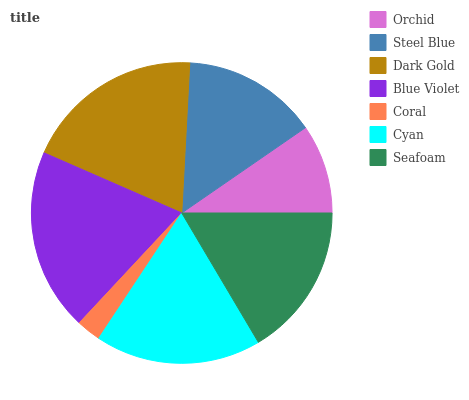Is Coral the minimum?
Answer yes or no. Yes. Is Blue Violet the maximum?
Answer yes or no. Yes. Is Steel Blue the minimum?
Answer yes or no. No. Is Steel Blue the maximum?
Answer yes or no. No. Is Steel Blue greater than Orchid?
Answer yes or no. Yes. Is Orchid less than Steel Blue?
Answer yes or no. Yes. Is Orchid greater than Steel Blue?
Answer yes or no. No. Is Steel Blue less than Orchid?
Answer yes or no. No. Is Seafoam the high median?
Answer yes or no. Yes. Is Seafoam the low median?
Answer yes or no. Yes. Is Blue Violet the high median?
Answer yes or no. No. Is Cyan the low median?
Answer yes or no. No. 